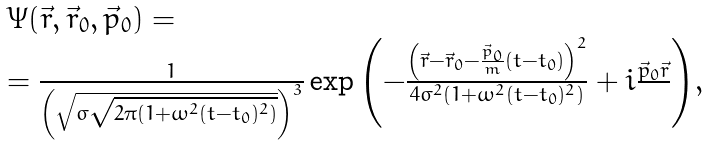Convert formula to latex. <formula><loc_0><loc_0><loc_500><loc_500>\begin{array} { l } \Psi ( \vec { r } , \vec { r } _ { 0 } , \vec { p } _ { 0 } ) = \\ = \frac { 1 } { \left ( { \sqrt { \sigma \sqrt { 2 \pi ( 1 + \omega ^ { 2 } ( t - t _ { 0 } ) ^ { 2 } ) } } } \right ) ^ { 3 } } \exp { \left ( { - \frac { \left ( { \vec { r } - \vec { r } _ { 0 } - \frac { \vec { p } _ { 0 } } { m } ( t - t _ { 0 } ) } \right ) ^ { 2 } } { 4 \sigma ^ { 2 } ( 1 + \omega ^ { 2 } ( t - t _ { 0 } ) ^ { 2 } ) } + i \frac { \vec { p } _ { 0 } \vec { r } } { } } \right ) } , \end{array}</formula> 